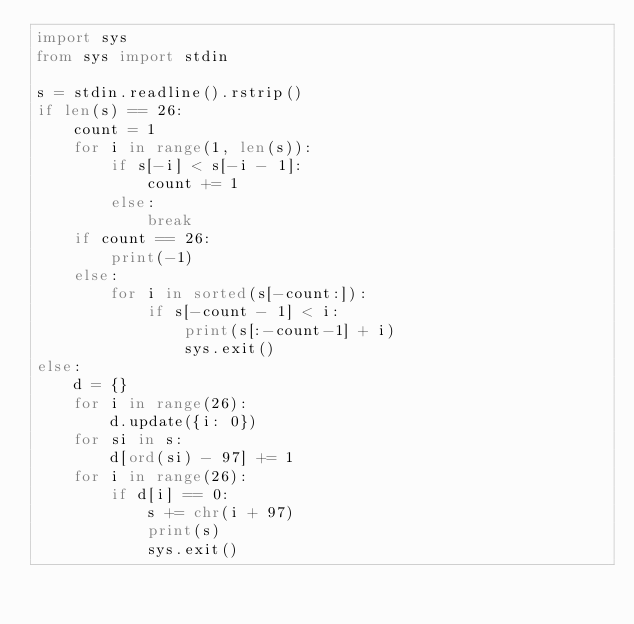<code> <loc_0><loc_0><loc_500><loc_500><_Python_>import sys
from sys import stdin

s = stdin.readline().rstrip()
if len(s) == 26:
    count = 1
    for i in range(1, len(s)):
        if s[-i] < s[-i - 1]:
            count += 1
        else:
            break
    if count == 26:
        print(-1)
    else:
        for i in sorted(s[-count:]):
            if s[-count - 1] < i:
                print(s[:-count-1] + i)
                sys.exit()
else:
    d = {}
    for i in range(26):
        d.update({i: 0})
    for si in s:
        d[ord(si) - 97] += 1
    for i in range(26):
        if d[i] == 0:
            s += chr(i + 97)
            print(s)
            sys.exit()
</code> 